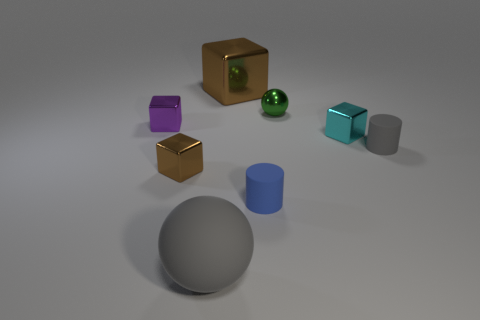There is a brown block that is in front of the matte cylinder behind the brown object that is in front of the tiny cyan cube; what is its size?
Offer a very short reply. Small. How many matte objects are either small gray blocks or large brown things?
Your answer should be very brief. 0. Is the shape of the large brown shiny object the same as the gray object that is to the right of the big gray rubber sphere?
Provide a succinct answer. No. Is the number of brown blocks that are behind the small green ball greater than the number of blue things that are to the right of the tiny gray rubber object?
Your response must be concise. Yes. Is there any other thing that is the same color as the large ball?
Give a very brief answer. Yes. There is a blue rubber thing that is in front of the gray thing on the right side of the small metal ball; are there any rubber balls that are to the right of it?
Your answer should be compact. No. There is a brown shiny object that is in front of the tiny green sphere; is its shape the same as the small gray object?
Your answer should be very brief. No. Are there fewer cyan blocks that are left of the small green metallic object than rubber balls that are behind the big matte thing?
Your response must be concise. No. What is the blue object made of?
Your answer should be very brief. Rubber. There is a matte ball; is its color the same as the cylinder that is on the right side of the green object?
Offer a very short reply. Yes. 